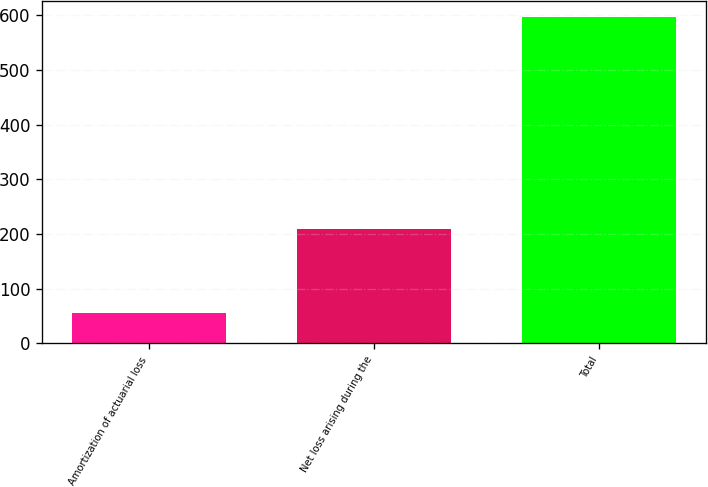<chart> <loc_0><loc_0><loc_500><loc_500><bar_chart><fcel>Amortization of actuarial loss<fcel>Net loss arising during the<fcel>Total<nl><fcel>56<fcel>209<fcel>597<nl></chart> 